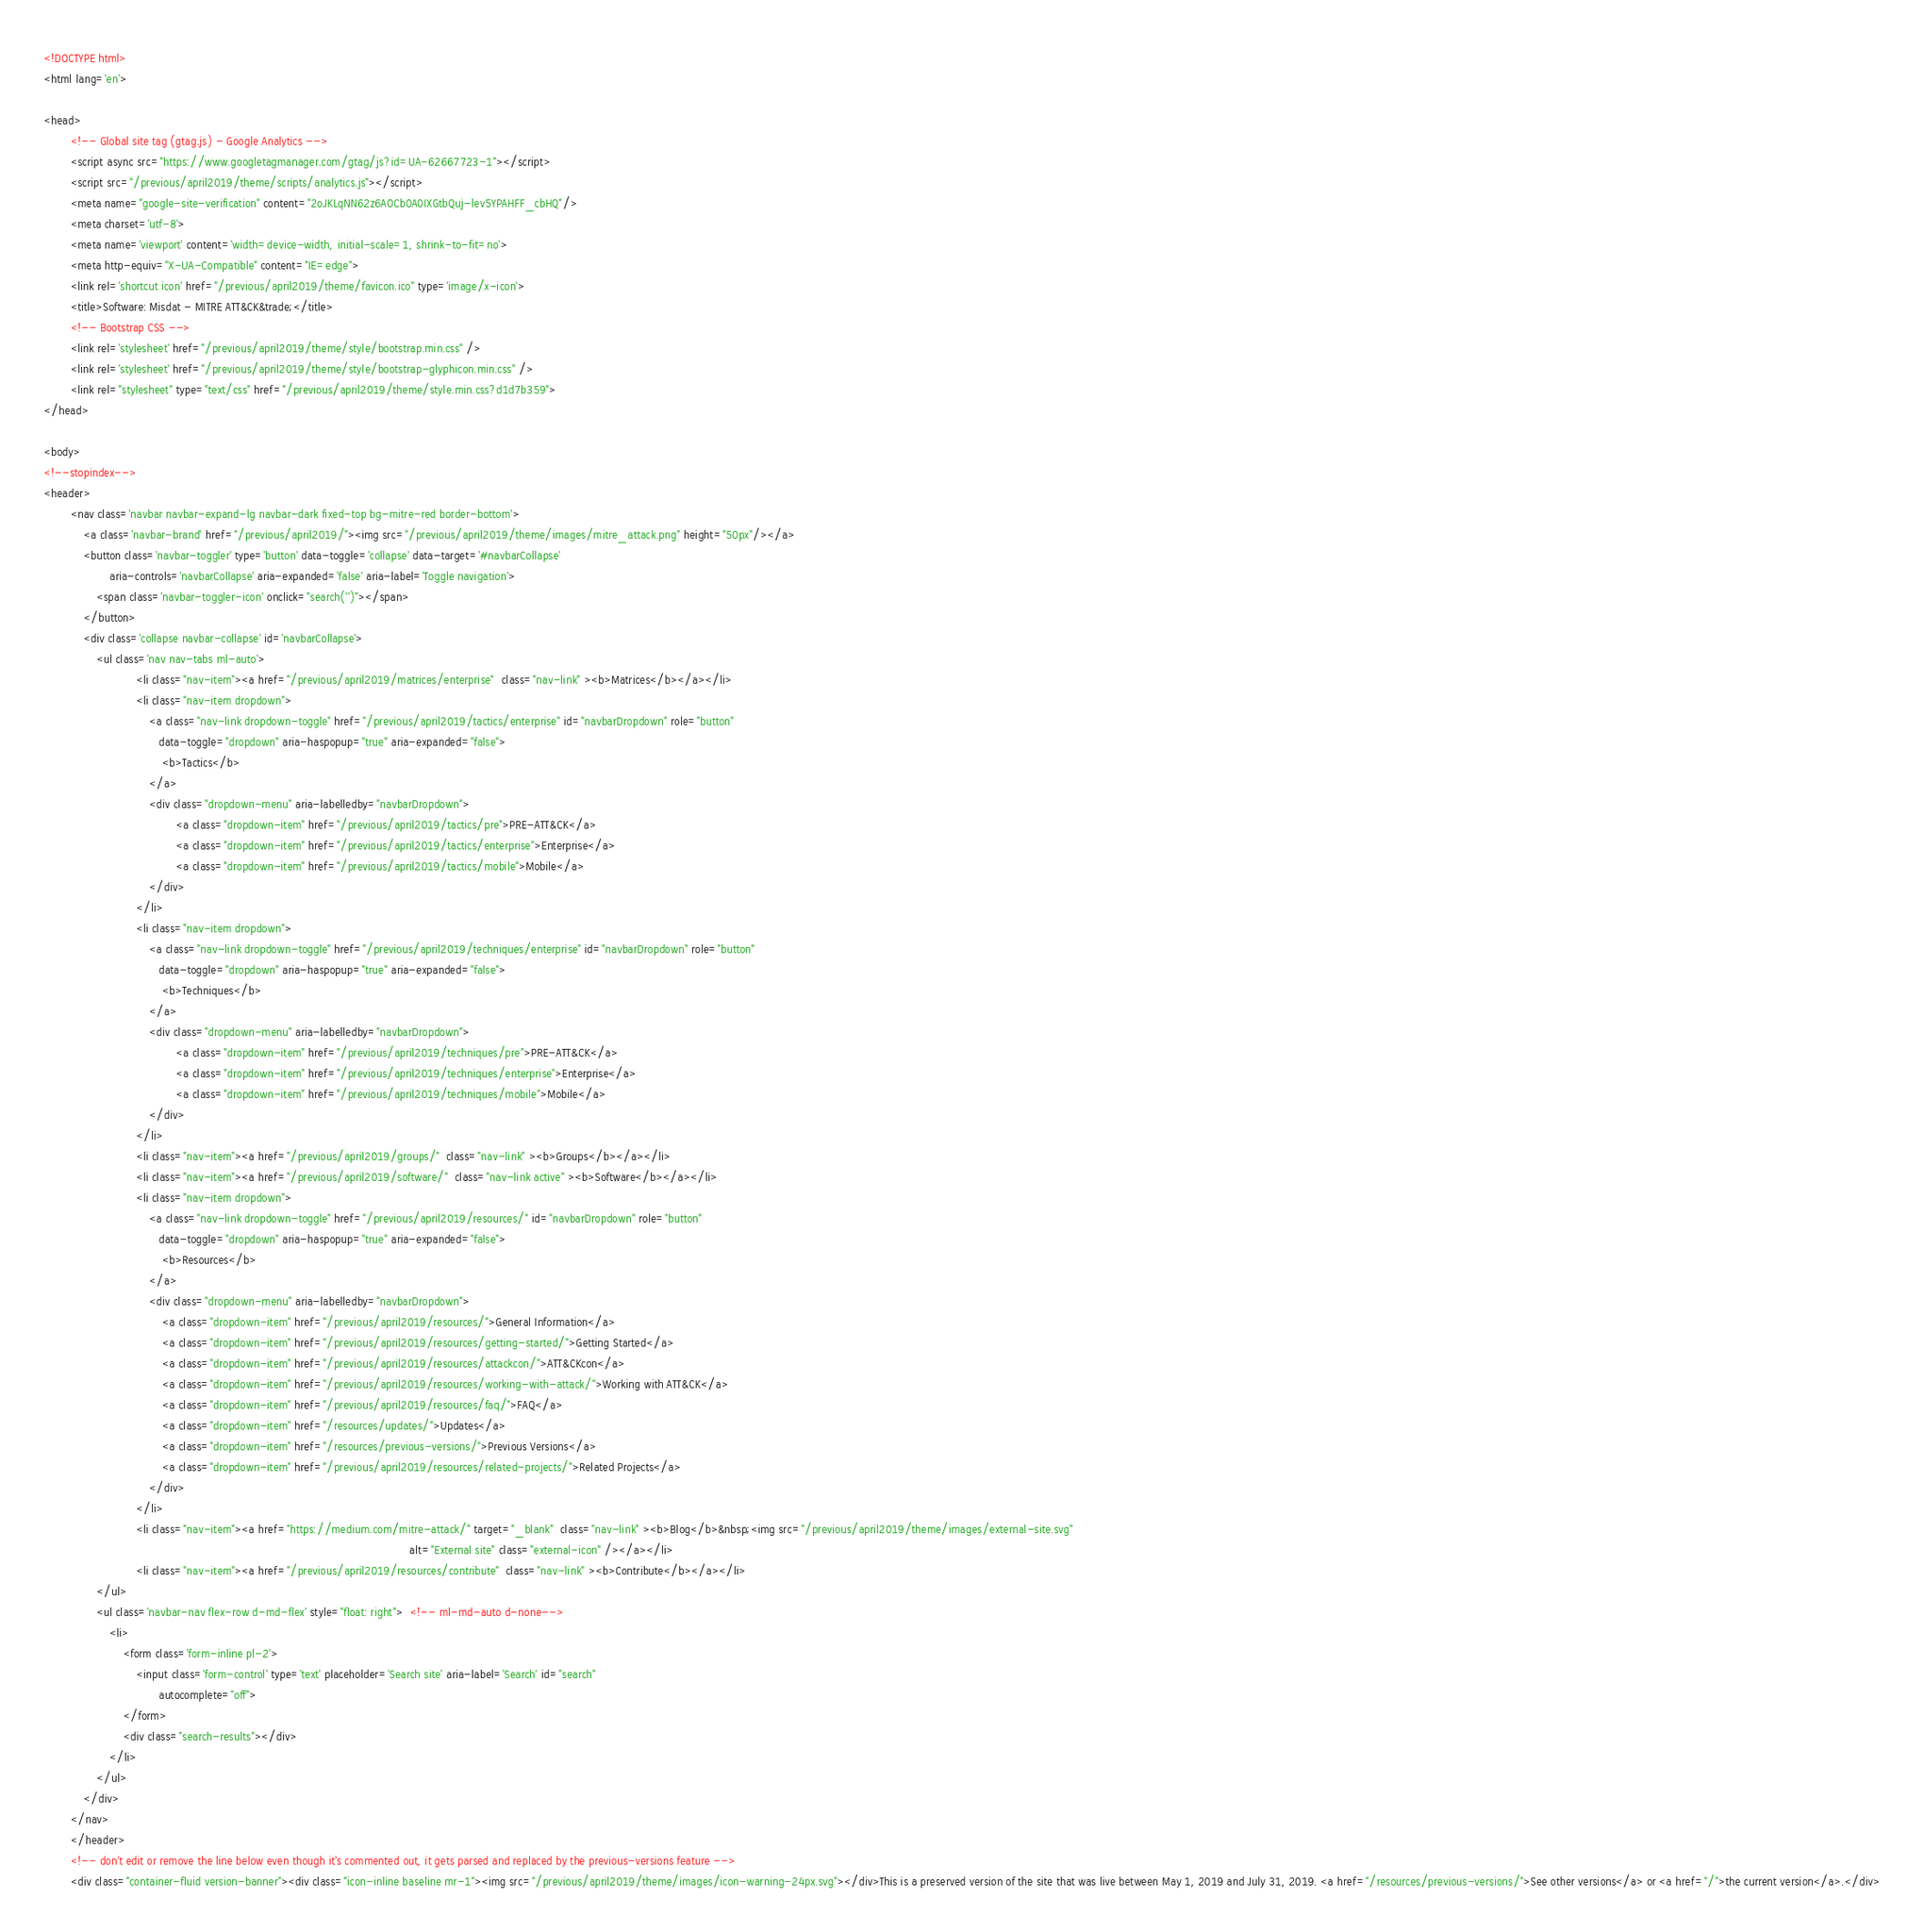<code> <loc_0><loc_0><loc_500><loc_500><_HTML_><!DOCTYPE html>
<html lang='en'>

<head>
        <!-- Global site tag (gtag.js) - Google Analytics -->
        <script async src="https://www.googletagmanager.com/gtag/js?id=UA-62667723-1"></script>
        <script src="/previous/april2019/theme/scripts/analytics.js"></script>
        <meta name="google-site-verification" content="2oJKLqNN62z6AOCb0A0IXGtbQuj-lev5YPAHFF_cbHQ"/>
        <meta charset='utf-8'>
        <meta name='viewport' content='width=device-width, initial-scale=1, shrink-to-fit=no'>
        <meta http-equiv="X-UA-Compatible" content="IE=edge">
        <link rel='shortcut icon' href="/previous/april2019/theme/favicon.ico" type='image/x-icon'>
        <title>Software: Misdat - MITRE ATT&CK&trade;</title>
        <!-- Bootstrap CSS -->
        <link rel='stylesheet' href="/previous/april2019/theme/style/bootstrap.min.css" />
        <link rel='stylesheet' href="/previous/april2019/theme/style/bootstrap-glyphicon.min.css" />
        <link rel="stylesheet" type="text/css" href="/previous/april2019/theme/style.min.css?d1d7b359">
</head>

<body>
<!--stopindex-->
<header>
        <nav class='navbar navbar-expand-lg navbar-dark fixed-top bg-mitre-red border-bottom'>
            <a class='navbar-brand' href="/previous/april2019/"><img src="/previous/april2019/theme/images/mitre_attack.png" height="50px"/></a>
            <button class='navbar-toggler' type='button' data-toggle='collapse' data-target='#navbarCollapse'
                    aria-controls='navbarCollapse' aria-expanded='false' aria-label='Toggle navigation'>
                <span class='navbar-toggler-icon' onclick="search('')"></span>
            </button>
            <div class='collapse navbar-collapse' id='navbarCollapse'>
                <ul class='nav nav-tabs ml-auto'>
                            <li class="nav-item"><a href="/previous/april2019/matrices/enterprise"  class="nav-link" ><b>Matrices</b></a></li>
                            <li class="nav-item dropdown">
                                <a class="nav-link dropdown-toggle" href="/previous/april2019/tactics/enterprise" id="navbarDropdown" role="button"
                                   data-toggle="dropdown" aria-haspopup="true" aria-expanded="false">
                                    <b>Tactics</b>
                                </a>
                                <div class="dropdown-menu" aria-labelledby="navbarDropdown">
                                        <a class="dropdown-item" href="/previous/april2019/tactics/pre">PRE-ATT&CK</a>
                                        <a class="dropdown-item" href="/previous/april2019/tactics/enterprise">Enterprise</a>
                                        <a class="dropdown-item" href="/previous/april2019/tactics/mobile">Mobile</a>
                                </div>
                            </li>
                            <li class="nav-item dropdown">
                                <a class="nav-link dropdown-toggle" href="/previous/april2019/techniques/enterprise" id="navbarDropdown" role="button"
                                   data-toggle="dropdown" aria-haspopup="true" aria-expanded="false">
                                    <b>Techniques</b>
                                </a>
                                <div class="dropdown-menu" aria-labelledby="navbarDropdown">
                                        <a class="dropdown-item" href="/previous/april2019/techniques/pre">PRE-ATT&CK</a>
                                        <a class="dropdown-item" href="/previous/april2019/techniques/enterprise">Enterprise</a>
                                        <a class="dropdown-item" href="/previous/april2019/techniques/mobile">Mobile</a>
                                </div>
                            </li>
                            <li class="nav-item"><a href="/previous/april2019/groups/"  class="nav-link" ><b>Groups</b></a></li>
                            <li class="nav-item"><a href="/previous/april2019/software/"  class="nav-link active" ><b>Software</b></a></li>
                            <li class="nav-item dropdown">
                                <a class="nav-link dropdown-toggle" href="/previous/april2019/resources/" id="navbarDropdown" role="button"
                                   data-toggle="dropdown" aria-haspopup="true" aria-expanded="false">
                                    <b>Resources</b>
                                </a>
                                <div class="dropdown-menu" aria-labelledby="navbarDropdown">
                                    <a class="dropdown-item" href="/previous/april2019/resources/">General Information</a>
                                    <a class="dropdown-item" href="/previous/april2019/resources/getting-started/">Getting Started</a>
                                    <a class="dropdown-item" href="/previous/april2019/resources/attackcon/">ATT&CKcon</a>
                                    <a class="dropdown-item" href="/previous/april2019/resources/working-with-attack/">Working with ATT&CK</a>
                                    <a class="dropdown-item" href="/previous/april2019/resources/faq/">FAQ</a>
                                    <a class="dropdown-item" href="/resources/updates/">Updates</a>
                                    <a class="dropdown-item" href="/resources/previous-versions/">Previous Versions</a>
                                    <a class="dropdown-item" href="/previous/april2019/resources/related-projects/">Related Projects</a>
                                </div>
                            </li>
                            <li class="nav-item"><a href="https://medium.com/mitre-attack/" target="_blank"  class="nav-link" ><b>Blog</b>&nbsp;<img src="/previous/april2019/theme/images/external-site.svg"
                                                                                                               alt="External site" class="external-icon" /></a></li>
                            <li class="nav-item"><a href="/previous/april2019/resources/contribute"  class="nav-link" ><b>Contribute</b></a></li>
                </ul>
                <ul class='navbar-nav flex-row d-md-flex' style="float: right">  <!-- ml-md-auto d-none-->
                    <li>
                        <form class='form-inline pl-2'>
                            <input class='form-control' type='text' placeholder='Search site' aria-label='Search' id="search"
                                   autocomplete="off">
                        </form>
                        <div class="search-results"></div>
                    </li>
                </ul>
            </div>
        </nav>
        </header>
        <!-- don't edit or remove the line below even though it's commented out, it gets parsed and replaced by the previous-versions feature -->
        <div class="container-fluid version-banner"><div class="icon-inline baseline mr-1"><img src="/previous/april2019/theme/images/icon-warning-24px.svg"></div>This is a preserved version of the site that was live between May 1, 2019 and July 31, 2019. <a href="/resources/previous-versions/">See other versions</a> or <a href="/">the current version</a>.</div></code> 